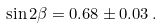Convert formula to latex. <formula><loc_0><loc_0><loc_500><loc_500>\sin 2 \beta = 0 . 6 8 \pm 0 . 0 3 \, .</formula> 